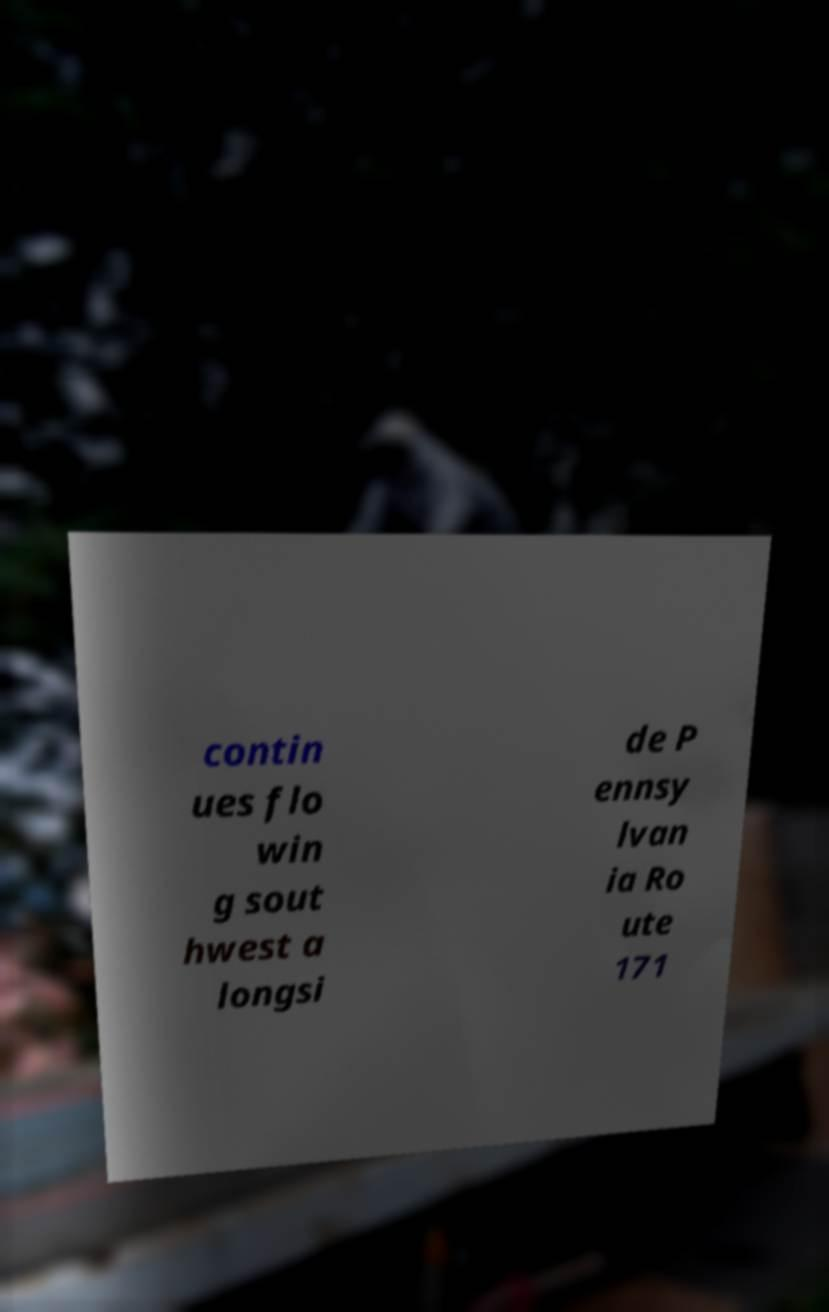Could you extract and type out the text from this image? contin ues flo win g sout hwest a longsi de P ennsy lvan ia Ro ute 171 